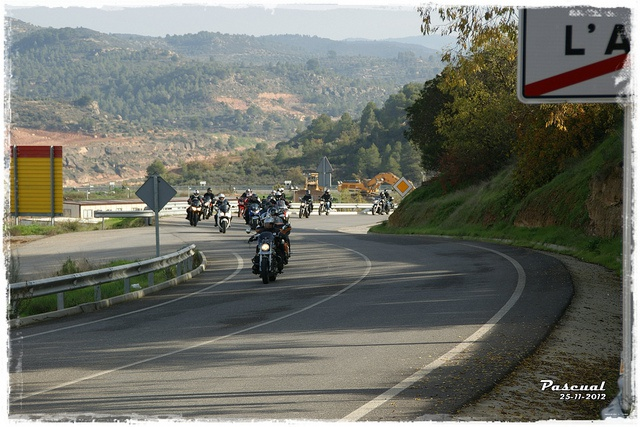Describe the objects in this image and their specific colors. I can see motorcycle in white, black, gray, darkblue, and darkgray tones, people in white, black, gray, and darkgray tones, people in white, black, gray, and darkblue tones, motorcycle in white, black, gray, navy, and darkgray tones, and motorcycle in white, black, gray, and darkgray tones in this image. 